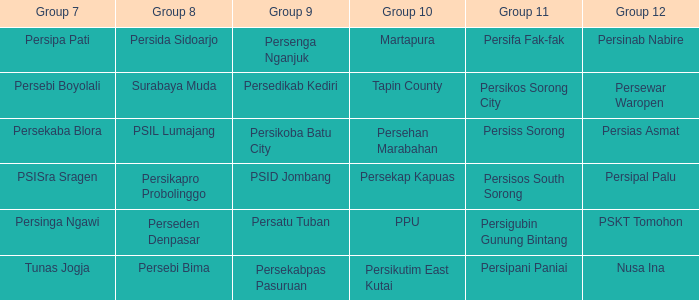Who played in group 12 when Group 9 played psid jombang? Persipal Palu. 